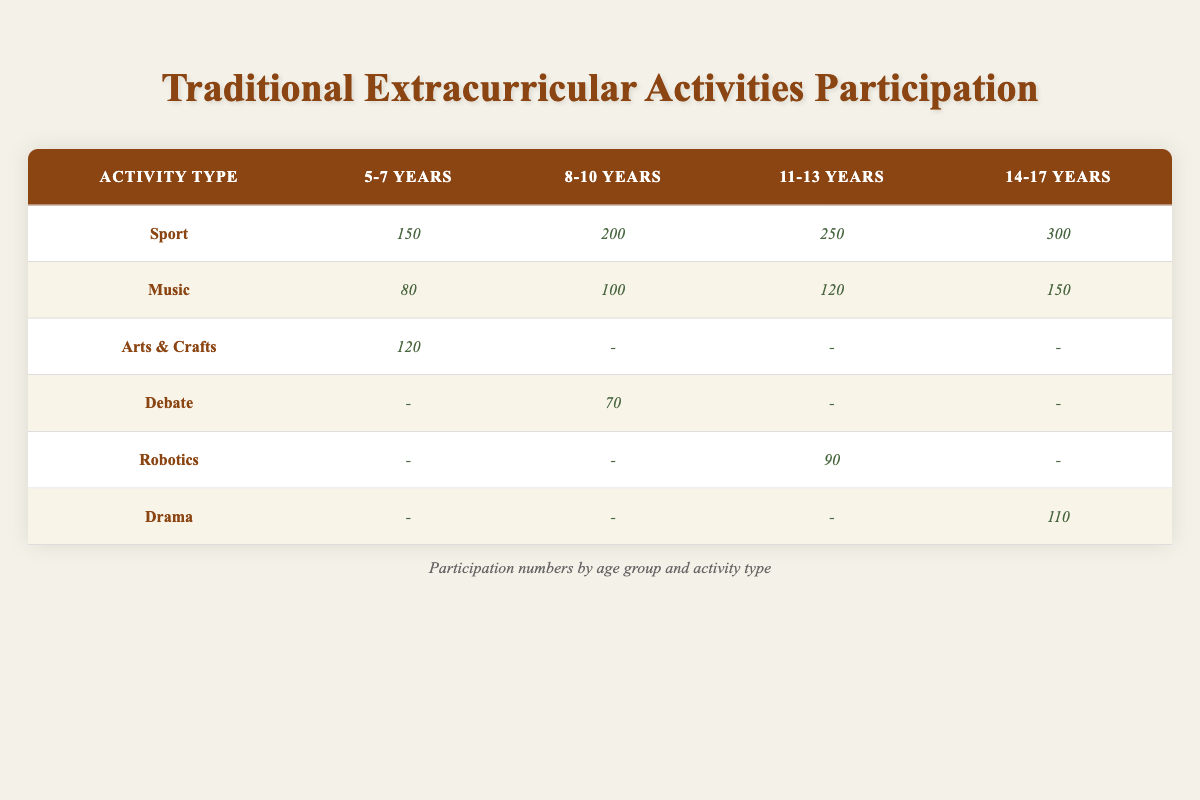What is the total number of participants in sports across all age groups? To find the total number of participants in sports, we look at the "Sport" row and sum the participants from all age groups. This includes 150 (5-7 years) + 200 (8-10 years) + 250 (11-13 years) + 300 (14-17 years) = 900.
Answer: 900 Which age group has the least number of participants in Music? We check the "Music" row and compare the values for each age group: 80 (5-7 years), 100 (8-10 years), 120 (11-13 years), and 150 (14-17 years). The least number is 80 for the 5-7 years age group.
Answer: 5-7 years Is there any age group that participates in Arts & Crafts other than 5-7 years? The table shows that Arts & Crafts has participants only in the 5-7 years age group with 120 participants and no data for other groups. Therefore, the answer is no.
Answer: No What is the difference between the highest and lowest number of participants in Drama? Looking at the "Drama" row shows that there are 110 participants in the 14-17 years age group and 0 in other groups. The difference between the highest (110) and the lowest (0) is 110.
Answer: 110 Which activity had the highest participation among 11-13 year-olds? We examine the participants for the age group 11-13 years: Sport (250), Music (120), and Robotics (90). The highest participation is in Sport with 250 participants.
Answer: Sport What is the average number of participants in Sports for the 5-7 and 8-10 year age groups combined? For 5-7 years, there are 150 participants and for 8-10 years, there are 200 participants. To find the average, we sum these values (150 + 200 = 350) and divide by the number of groups (2). Thus, the average is 350 / 2 = 175.
Answer: 175 Does Robotics have participants in age groups 5-7 or 8-10? Checking the "Robotics" row reveals that there are no participants in either of those age groups, as data shows participants only in 11-13 years (90). So the answer is no.
Answer: No How many more participants are there in Music for the 14-17 age group compared to the 8-10 age group? For Music, the 14-17 age group has 150 participants while the 8-10 age group has 100 participants. The difference is calculated as 150 - 100 = 50.
Answer: 50 Which activity type has the least overall participation across all age groups? By summing each activity type: Art & Crafts has 120 (only in 5-7 years), Debate has 70 (only in 8-10 years), Robotics has 90 (only in 11-13 years), and Drama has 110 (only in 14-17 years). The lowest total participation is in Debate with 70 participants.
Answer: Debate 